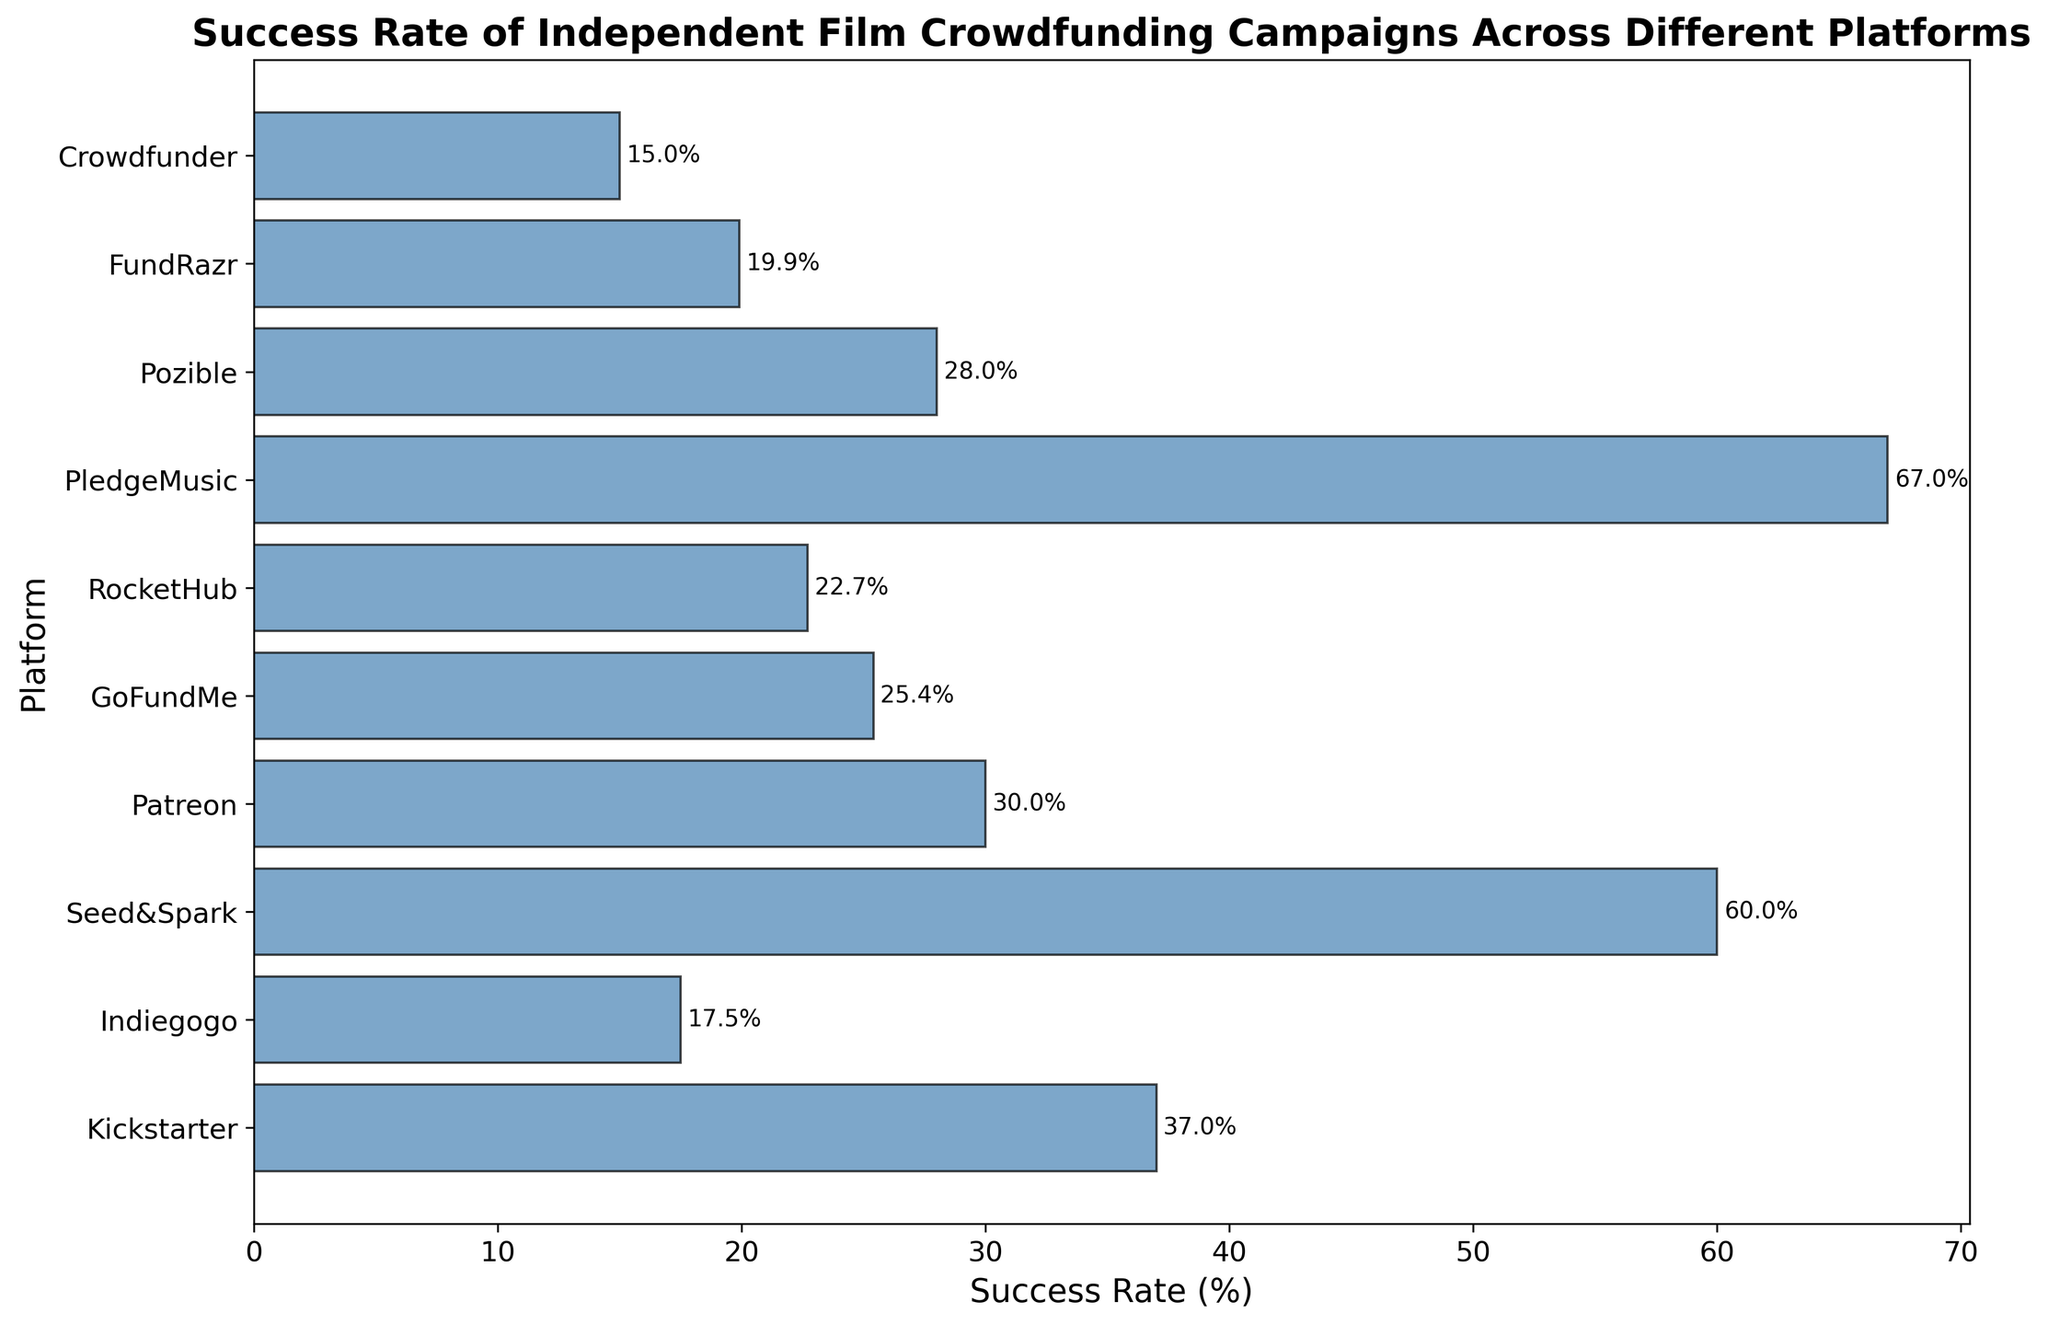Which platform has the highest success rate for independent film crowdfunding campaigns? To determine the platform with the highest success rate, look for the tallest bar (rightmost end) in the chart.
Answer: PledgeMusic What is the difference in success rate between Kickstarter and Indiegogo? Identify the heights of the bars for Kickstarter (37%) and Indiegogo (17.5%), and compute the difference: 37% - 17.5% = 19.5%
Answer: 19.5% Which platform has a higher success rate: Patreon or GoFundMe? Compare the heights of the bars for Patreon (30%) and GoFundMe (25.4%). Patreon has a higher bar.
Answer: Patreon What is the median success rate of the platforms? Arrange the success rates in ascending order and find the middle value. The ordered rates are: 15, 17.5, 19.9, 22.7, 25.4, 28, 30, 37, 60, 67. The median value is the average of 25.4 and 28: (25.4 + 28) / 2 = 26.7
Answer: 26.7 How many platforms have a success rate below 25%? Count the bars with heights below 25%: Indiegogo (17.5%), FundRazr (19.9%), RocketHub (22.7%), and Crowdfunder (15%). Altogether, there are 4.
Answer: 4 What is the average success rate of all the platforms listed? Sum all the success rates and divide by the number of platforms: (37 + 17.5 + 60 + 30 + 25.4 + 22.7 + 67 + 28 + 19.9 + 15) / 10 = 32.65
Answer: 32.65 Is the success rate of Kickstarter greater than the average success rate of all the platforms? The average success rate is 32.65% and the success rate of Kickstarter is 37%. Since 37% > 32.65%, Kickstarter's success rate is greater.
Answer: Yes What is the success rate difference between the highest and the lowest platform? The highest success rate is 67% (PledgeMusic) and the lowest is 15% (Crowdfunder). The difference is 67% - 15% = 52%
Answer: 52% Which two platforms have the closest success rates, and what is that difference? Identify the pairs with the smallest difference: GoFundMe (25.4%) and Pozible (28%) have the closest rates with a difference of 28% - 25.4% = 2.6%
Answer: GoFundMe, Pozible (2.6%) 